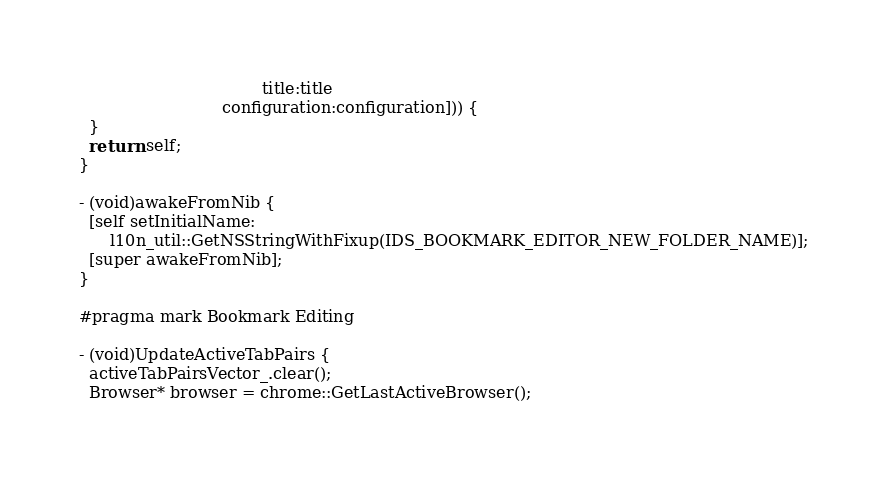<code> <loc_0><loc_0><loc_500><loc_500><_ObjectiveC_>                                    title:title
                            configuration:configuration])) {
  }
  return self;
}

- (void)awakeFromNib {
  [self setInitialName:
      l10n_util::GetNSStringWithFixup(IDS_BOOKMARK_EDITOR_NEW_FOLDER_NAME)];
  [super awakeFromNib];
}

#pragma mark Bookmark Editing

- (void)UpdateActiveTabPairs {
  activeTabPairsVector_.clear();
  Browser* browser = chrome::GetLastActiveBrowser();</code> 